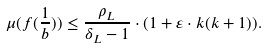<formula> <loc_0><loc_0><loc_500><loc_500>\mu ( f ( \frac { 1 } { b } ) ) \leq \frac { \rho _ { L } } { \delta _ { L } - 1 } \cdot ( 1 + \varepsilon \cdot k ( k + 1 ) ) .</formula> 